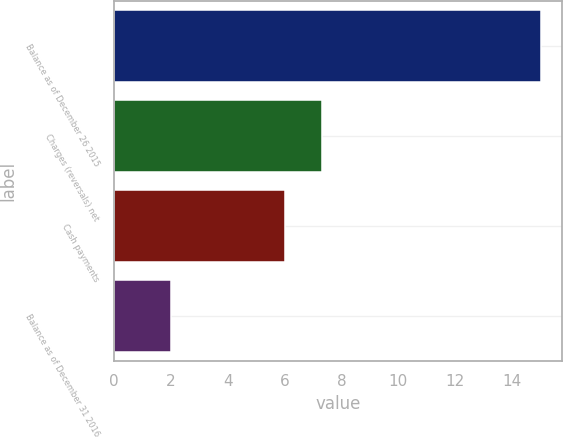Convert chart to OTSL. <chart><loc_0><loc_0><loc_500><loc_500><bar_chart><fcel>Balance as of December 26 2015<fcel>Charges (reversals) net<fcel>Cash payments<fcel>Balance as of December 31 2016<nl><fcel>15<fcel>7.3<fcel>6<fcel>2<nl></chart> 